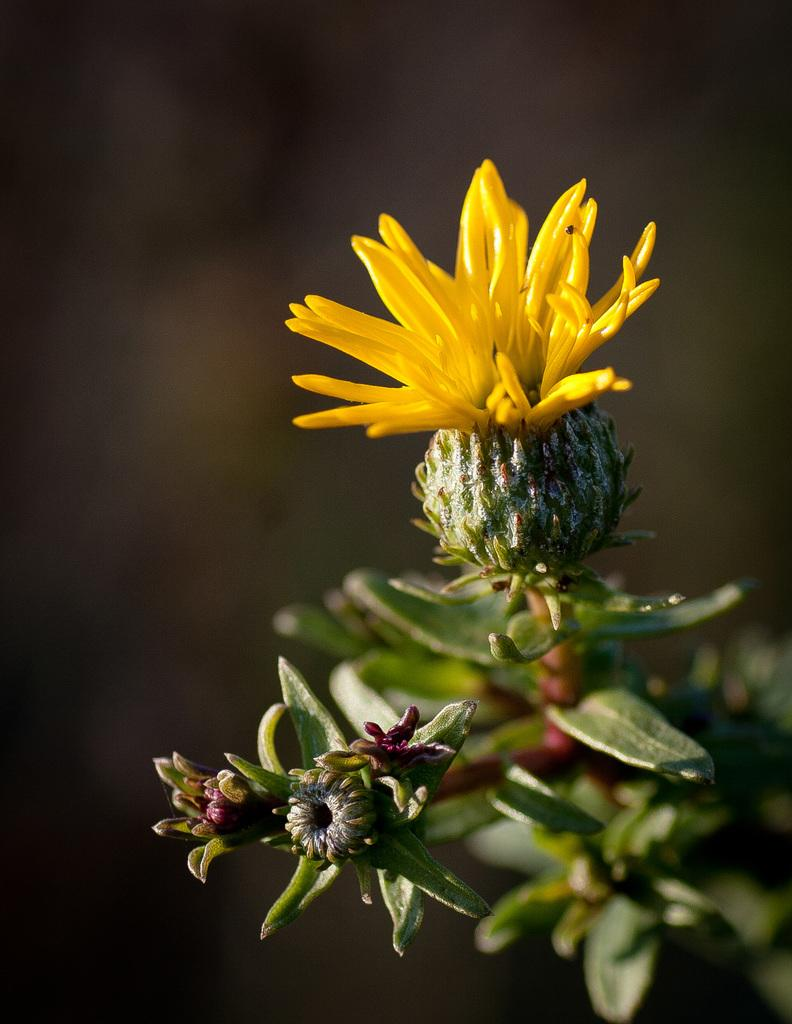What type of plant can be seen in the image? There is a flower in the image. What stage of growth are some of the flowers in the image? There are buds in the image, which indicates that some flowers are in the early stages of growth. What parts of the plant are visible in the image? There are stems and leaves in the image. How would you describe the background of the image? The background of the image is blurry. What type of quicksand can be seen in the image? There is no quicksand present in the image; it features a flower with buds, stems, and leaves. 